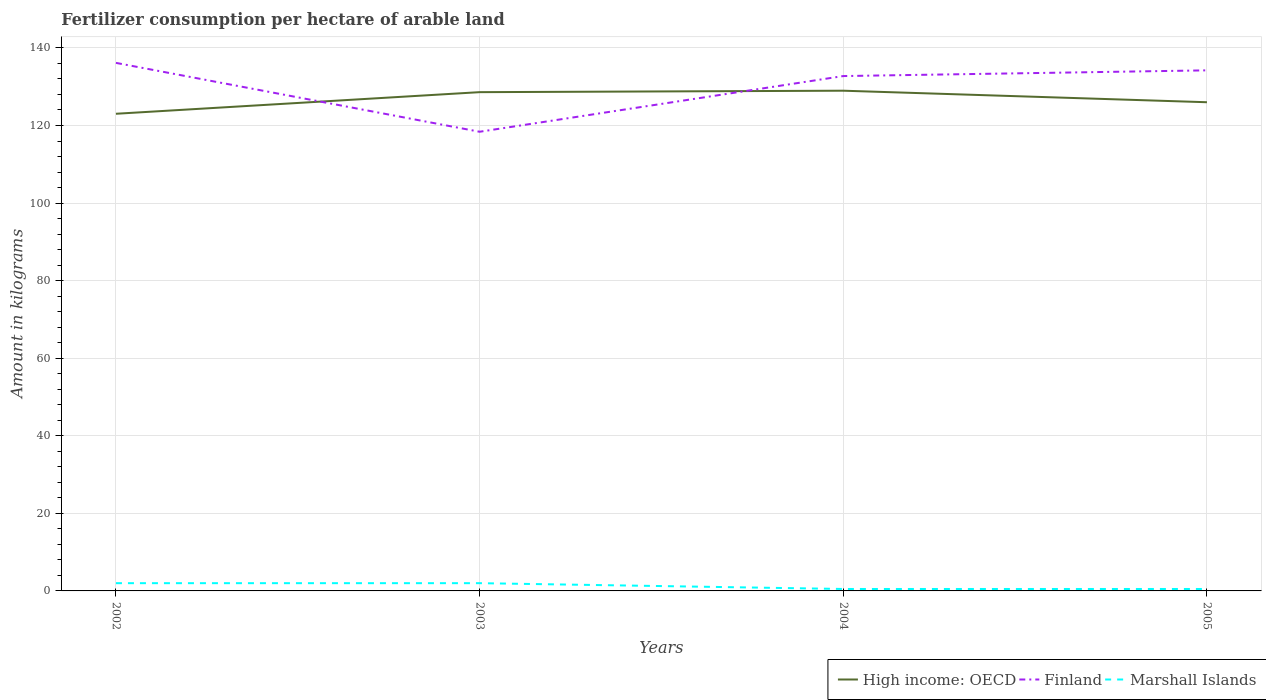Does the line corresponding to Finland intersect with the line corresponding to Marshall Islands?
Provide a succinct answer. No. Is the number of lines equal to the number of legend labels?
Give a very brief answer. Yes. In which year was the amount of fertilizer consumption in Marshall Islands maximum?
Your response must be concise. 2004. What is the total amount of fertilizer consumption in High income: OECD in the graph?
Provide a short and direct response. -2.97. What is the difference between the highest and the second highest amount of fertilizer consumption in Marshall Islands?
Ensure brevity in your answer.  1.5. Does the graph contain grids?
Ensure brevity in your answer.  Yes. Where does the legend appear in the graph?
Ensure brevity in your answer.  Bottom right. What is the title of the graph?
Provide a short and direct response. Fertilizer consumption per hectare of arable land. What is the label or title of the Y-axis?
Your answer should be very brief. Amount in kilograms. What is the Amount in kilograms in High income: OECD in 2002?
Give a very brief answer. 123.02. What is the Amount in kilograms in Finland in 2002?
Give a very brief answer. 136.14. What is the Amount in kilograms in Marshall Islands in 2002?
Offer a terse response. 2. What is the Amount in kilograms of High income: OECD in 2003?
Provide a succinct answer. 128.59. What is the Amount in kilograms in Finland in 2003?
Provide a succinct answer. 118.39. What is the Amount in kilograms in Marshall Islands in 2003?
Make the answer very short. 2. What is the Amount in kilograms of High income: OECD in 2004?
Offer a terse response. 128.97. What is the Amount in kilograms in Finland in 2004?
Your answer should be very brief. 132.75. What is the Amount in kilograms in Marshall Islands in 2004?
Keep it short and to the point. 0.5. What is the Amount in kilograms in High income: OECD in 2005?
Offer a terse response. 126. What is the Amount in kilograms in Finland in 2005?
Offer a terse response. 134.22. What is the Amount in kilograms in Marshall Islands in 2005?
Give a very brief answer. 0.5. Across all years, what is the maximum Amount in kilograms of High income: OECD?
Provide a short and direct response. 128.97. Across all years, what is the maximum Amount in kilograms of Finland?
Give a very brief answer. 136.14. Across all years, what is the maximum Amount in kilograms of Marshall Islands?
Give a very brief answer. 2. Across all years, what is the minimum Amount in kilograms in High income: OECD?
Keep it short and to the point. 123.02. Across all years, what is the minimum Amount in kilograms of Finland?
Ensure brevity in your answer.  118.39. What is the total Amount in kilograms of High income: OECD in the graph?
Keep it short and to the point. 506.58. What is the total Amount in kilograms in Finland in the graph?
Ensure brevity in your answer.  521.49. What is the difference between the Amount in kilograms in High income: OECD in 2002 and that in 2003?
Provide a succinct answer. -5.57. What is the difference between the Amount in kilograms in Finland in 2002 and that in 2003?
Provide a succinct answer. 17.76. What is the difference between the Amount in kilograms in Marshall Islands in 2002 and that in 2003?
Provide a short and direct response. 0. What is the difference between the Amount in kilograms of High income: OECD in 2002 and that in 2004?
Offer a terse response. -5.94. What is the difference between the Amount in kilograms of Finland in 2002 and that in 2004?
Your response must be concise. 3.4. What is the difference between the Amount in kilograms of High income: OECD in 2002 and that in 2005?
Keep it short and to the point. -2.97. What is the difference between the Amount in kilograms of Finland in 2002 and that in 2005?
Provide a succinct answer. 1.93. What is the difference between the Amount in kilograms in Marshall Islands in 2002 and that in 2005?
Offer a terse response. 1.5. What is the difference between the Amount in kilograms in High income: OECD in 2003 and that in 2004?
Your response must be concise. -0.37. What is the difference between the Amount in kilograms in Finland in 2003 and that in 2004?
Your answer should be very brief. -14.36. What is the difference between the Amount in kilograms of High income: OECD in 2003 and that in 2005?
Give a very brief answer. 2.6. What is the difference between the Amount in kilograms in Finland in 2003 and that in 2005?
Provide a short and direct response. -15.83. What is the difference between the Amount in kilograms in Marshall Islands in 2003 and that in 2005?
Keep it short and to the point. 1.5. What is the difference between the Amount in kilograms of High income: OECD in 2004 and that in 2005?
Give a very brief answer. 2.97. What is the difference between the Amount in kilograms of Finland in 2004 and that in 2005?
Provide a short and direct response. -1.47. What is the difference between the Amount in kilograms in High income: OECD in 2002 and the Amount in kilograms in Finland in 2003?
Offer a terse response. 4.64. What is the difference between the Amount in kilograms of High income: OECD in 2002 and the Amount in kilograms of Marshall Islands in 2003?
Offer a terse response. 121.02. What is the difference between the Amount in kilograms of Finland in 2002 and the Amount in kilograms of Marshall Islands in 2003?
Offer a terse response. 134.14. What is the difference between the Amount in kilograms of High income: OECD in 2002 and the Amount in kilograms of Finland in 2004?
Offer a terse response. -9.72. What is the difference between the Amount in kilograms in High income: OECD in 2002 and the Amount in kilograms in Marshall Islands in 2004?
Your answer should be compact. 122.52. What is the difference between the Amount in kilograms of Finland in 2002 and the Amount in kilograms of Marshall Islands in 2004?
Offer a terse response. 135.64. What is the difference between the Amount in kilograms in High income: OECD in 2002 and the Amount in kilograms in Finland in 2005?
Provide a short and direct response. -11.19. What is the difference between the Amount in kilograms of High income: OECD in 2002 and the Amount in kilograms of Marshall Islands in 2005?
Make the answer very short. 122.52. What is the difference between the Amount in kilograms of Finland in 2002 and the Amount in kilograms of Marshall Islands in 2005?
Your response must be concise. 135.64. What is the difference between the Amount in kilograms of High income: OECD in 2003 and the Amount in kilograms of Finland in 2004?
Your answer should be compact. -4.15. What is the difference between the Amount in kilograms of High income: OECD in 2003 and the Amount in kilograms of Marshall Islands in 2004?
Provide a short and direct response. 128.09. What is the difference between the Amount in kilograms of Finland in 2003 and the Amount in kilograms of Marshall Islands in 2004?
Ensure brevity in your answer.  117.89. What is the difference between the Amount in kilograms in High income: OECD in 2003 and the Amount in kilograms in Finland in 2005?
Provide a succinct answer. -5.62. What is the difference between the Amount in kilograms of High income: OECD in 2003 and the Amount in kilograms of Marshall Islands in 2005?
Ensure brevity in your answer.  128.09. What is the difference between the Amount in kilograms in Finland in 2003 and the Amount in kilograms in Marshall Islands in 2005?
Offer a very short reply. 117.89. What is the difference between the Amount in kilograms of High income: OECD in 2004 and the Amount in kilograms of Finland in 2005?
Keep it short and to the point. -5.25. What is the difference between the Amount in kilograms in High income: OECD in 2004 and the Amount in kilograms in Marshall Islands in 2005?
Ensure brevity in your answer.  128.47. What is the difference between the Amount in kilograms of Finland in 2004 and the Amount in kilograms of Marshall Islands in 2005?
Provide a succinct answer. 132.25. What is the average Amount in kilograms of High income: OECD per year?
Give a very brief answer. 126.65. What is the average Amount in kilograms in Finland per year?
Provide a succinct answer. 130.37. In the year 2002, what is the difference between the Amount in kilograms of High income: OECD and Amount in kilograms of Finland?
Give a very brief answer. -13.12. In the year 2002, what is the difference between the Amount in kilograms of High income: OECD and Amount in kilograms of Marshall Islands?
Give a very brief answer. 121.02. In the year 2002, what is the difference between the Amount in kilograms in Finland and Amount in kilograms in Marshall Islands?
Make the answer very short. 134.14. In the year 2003, what is the difference between the Amount in kilograms of High income: OECD and Amount in kilograms of Finland?
Ensure brevity in your answer.  10.21. In the year 2003, what is the difference between the Amount in kilograms in High income: OECD and Amount in kilograms in Marshall Islands?
Provide a succinct answer. 126.59. In the year 2003, what is the difference between the Amount in kilograms of Finland and Amount in kilograms of Marshall Islands?
Your response must be concise. 116.39. In the year 2004, what is the difference between the Amount in kilograms in High income: OECD and Amount in kilograms in Finland?
Ensure brevity in your answer.  -3.78. In the year 2004, what is the difference between the Amount in kilograms in High income: OECD and Amount in kilograms in Marshall Islands?
Keep it short and to the point. 128.47. In the year 2004, what is the difference between the Amount in kilograms in Finland and Amount in kilograms in Marshall Islands?
Your response must be concise. 132.25. In the year 2005, what is the difference between the Amount in kilograms of High income: OECD and Amount in kilograms of Finland?
Offer a terse response. -8.22. In the year 2005, what is the difference between the Amount in kilograms of High income: OECD and Amount in kilograms of Marshall Islands?
Your answer should be very brief. 125.5. In the year 2005, what is the difference between the Amount in kilograms in Finland and Amount in kilograms in Marshall Islands?
Make the answer very short. 133.72. What is the ratio of the Amount in kilograms in High income: OECD in 2002 to that in 2003?
Your answer should be very brief. 0.96. What is the ratio of the Amount in kilograms in Finland in 2002 to that in 2003?
Offer a very short reply. 1.15. What is the ratio of the Amount in kilograms in Marshall Islands in 2002 to that in 2003?
Ensure brevity in your answer.  1. What is the ratio of the Amount in kilograms in High income: OECD in 2002 to that in 2004?
Provide a succinct answer. 0.95. What is the ratio of the Amount in kilograms in Finland in 2002 to that in 2004?
Provide a short and direct response. 1.03. What is the ratio of the Amount in kilograms of Marshall Islands in 2002 to that in 2004?
Give a very brief answer. 4. What is the ratio of the Amount in kilograms of High income: OECD in 2002 to that in 2005?
Provide a succinct answer. 0.98. What is the ratio of the Amount in kilograms in Finland in 2002 to that in 2005?
Your response must be concise. 1.01. What is the ratio of the Amount in kilograms in Marshall Islands in 2002 to that in 2005?
Your answer should be very brief. 4. What is the ratio of the Amount in kilograms of Finland in 2003 to that in 2004?
Make the answer very short. 0.89. What is the ratio of the Amount in kilograms in Marshall Islands in 2003 to that in 2004?
Offer a terse response. 4. What is the ratio of the Amount in kilograms of High income: OECD in 2003 to that in 2005?
Offer a terse response. 1.02. What is the ratio of the Amount in kilograms in Finland in 2003 to that in 2005?
Provide a succinct answer. 0.88. What is the ratio of the Amount in kilograms of Marshall Islands in 2003 to that in 2005?
Provide a succinct answer. 4. What is the ratio of the Amount in kilograms of High income: OECD in 2004 to that in 2005?
Keep it short and to the point. 1.02. What is the ratio of the Amount in kilograms of Finland in 2004 to that in 2005?
Provide a succinct answer. 0.99. What is the ratio of the Amount in kilograms in Marshall Islands in 2004 to that in 2005?
Your answer should be compact. 1. What is the difference between the highest and the second highest Amount in kilograms of High income: OECD?
Provide a short and direct response. 0.37. What is the difference between the highest and the second highest Amount in kilograms of Finland?
Your answer should be compact. 1.93. What is the difference between the highest and the lowest Amount in kilograms of High income: OECD?
Provide a short and direct response. 5.94. What is the difference between the highest and the lowest Amount in kilograms of Finland?
Your answer should be compact. 17.76. What is the difference between the highest and the lowest Amount in kilograms of Marshall Islands?
Your response must be concise. 1.5. 